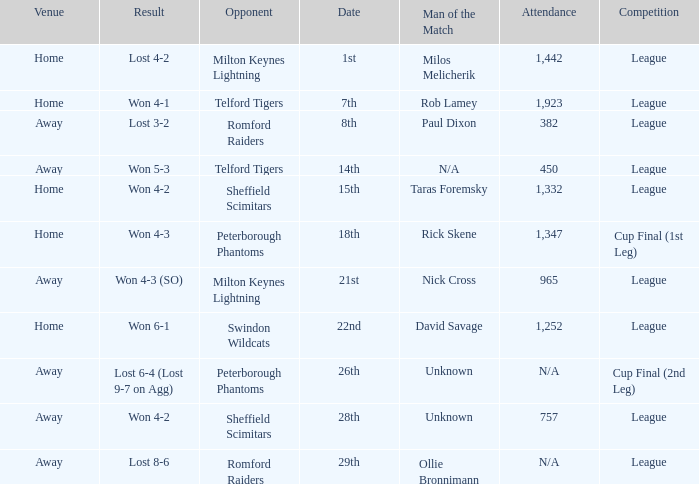Who was the Man of the Match when the opponent was Milton Keynes Lightning and the venue was Away? Nick Cross. 